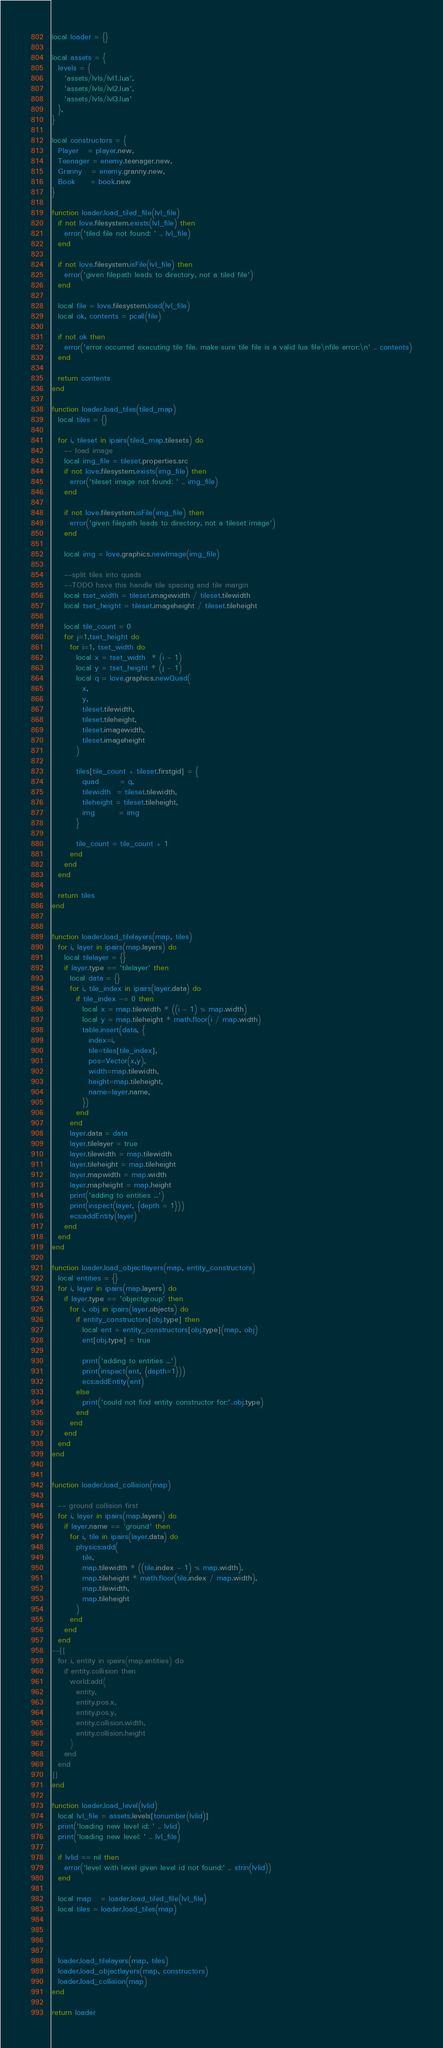Convert code to text. <code><loc_0><loc_0><loc_500><loc_500><_Lua_>local loader = {}

local assets = {
  levels = {
    'assets/lvls/lvl1.lua',
    'assets/lvls/lvl2.lua',
    'assets/lvls/lvl3.lua'
  },
}

local constructors = {
  Player   = player.new,
  Teenager = enemy.teenager.new,
  Granny   = enemy.granny.new,
  Book     = book.new
}

function loader.load_tiled_file(lvl_file)
  if not love.filesystem.exists(lvl_file) then
    error('tiled file not found: ' .. lvl_file)
  end

  if not love.filesystem.isFile(lvl_file) then
    error('given filepath leads to directory, not a tiled file')
  end

  local file = love.filesystem.load(lvl_file)
  local ok, contents = pcall(file)
  
  if not ok then 
    error('error occurred executing tile file. make sure tile file is a valid lua file\nfile error:\n' .. contents)
  end

  return contents
end

function loader.load_tiles(tiled_map)
  local tiles = {}

  for i, tileset in ipairs(tiled_map.tilesets) do
    -- load image
    local img_file = tileset.properties.src
    if not love.filesystem.exists(img_file) then
      error('tileset image not found: ' .. img_file)
    end

    if not love.filesystem.isFile(img_file) then
      error('given filepath leads to directory, not a tileset image')
    end

    local img = love.graphics.newImage(img_file)

    --split tiles into quads
    --TODO have this handle tile spacing and tile margin
    local tset_width = tileset.imagewidth / tileset.tilewidth
    local tset_height = tileset.imageheight / tileset.tileheight

    local tile_count = 0
    for j=1,tset_height do
      for i=1, tset_width do
        local x = tset_width  * (i - 1)
        local y = tset_height * (j - 1)
        local q = love.graphics.newQuad(
          x,
          y,
          tileset.tilewidth,
          tileset.tileheight,
          tileset.imagewidth,
          tileset.imageheight
        )

        tiles[tile_count + tileset.firstgid] = {
          quad       = q,
          tilewidth  = tileset.tilewidth,
          tileheight = tileset.tileheight,
          img        = img
        }

        tile_count = tile_count + 1
      end
    end
  end

  return tiles
end


function loader.load_tilelayers(map, tiles)
  for i, layer in ipairs(map.layers) do
    local tilelayer = {}
    if layer.type == 'tilelayer' then
      local data = {}
      for i, tile_index in ipairs(layer.data) do
        if tile_index ~= 0 then
          local x = map.tilewidth * ((i - 1) % map.width)
          local y = map.tileheight * math.floor(i / map.width)
          table.insert(data, {
            index=i,
            tile=tiles[tile_index],
            pos=Vector(x,y),
            width=map.tilewidth,
            height=map.tileheight,
            name=layer.name,
          })
        end
      end
      layer.data = data
      layer.tilelayer = true
      layer.tilewidth = map.tilewidth
      layer.tileheight = map.tileheight
      layer.mapwidth = map.width
      layer.mapheight = map.height
      print('adding to entities ...')
      print(inspect(layer, {depth = 1}))
      ecs:addEntity(layer)
    end
  end
end

function loader.load_objectlayers(map, entity_constructors)
  local entities = {}
  for i, layer in ipairs(map.layers) do
    if layer.type == 'objectgroup' then
      for i, obj in ipairs(layer.objects) do
        if entity_constructors[obj.type] then
          local ent = entity_constructors[obj.type](map, obj)
          ent[obj.type] = true

          print('adding to entities ...')
          print(inspect(ent, {depth=1}))
          ecs:addEntity(ent)
        else
          print('could not find entity constructor for:'..obj.type)
        end
      end
    end
  end
end


function loader.load_collision(map)

  -- ground collision first
  for i, layer in ipairs(map.layers) do
    if layer.name == 'ground' then
      for i, tile in ipairs(layer.data) do
        physics:add(
          tile, 
          map.tilewidth * ((tile.index - 1) % map.width),
          map.tileheight * math.floor(tile.index / map.width),
          map.tilewidth,
          map.tileheight
        )
      end
    end
  end
--[[
  for i, entity in ipairs(map.entities) do
    if entity.collision then
      world:add(
        entity,
        entity.pos.x,
        entity.pos.y,
        entity.collision.width,
        entity.collision.height
      )
    end
  end
]]
end

function loader.load_level(lvlid)
  local lvl_file = assets.levels[tonumber(lvlid)]
  print('loading new level id: ' .. lvlid)
  print('loading new level: ' .. lvl_file)

  if lvlid == nil then
    error('level with level given level id not found:' .. strin(lvlid))
  end

  local map   = loader.load_tiled_file(lvl_file)
  local tiles = loader.load_tiles(map)




  loader.load_tilelayers(map, tiles)
  loader.load_objectlayers(map, constructors)
  loader.load_collision(map)
end

return loader
</code> 